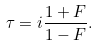Convert formula to latex. <formula><loc_0><loc_0><loc_500><loc_500>\tau = i \frac { 1 + F } { 1 - F } .</formula> 